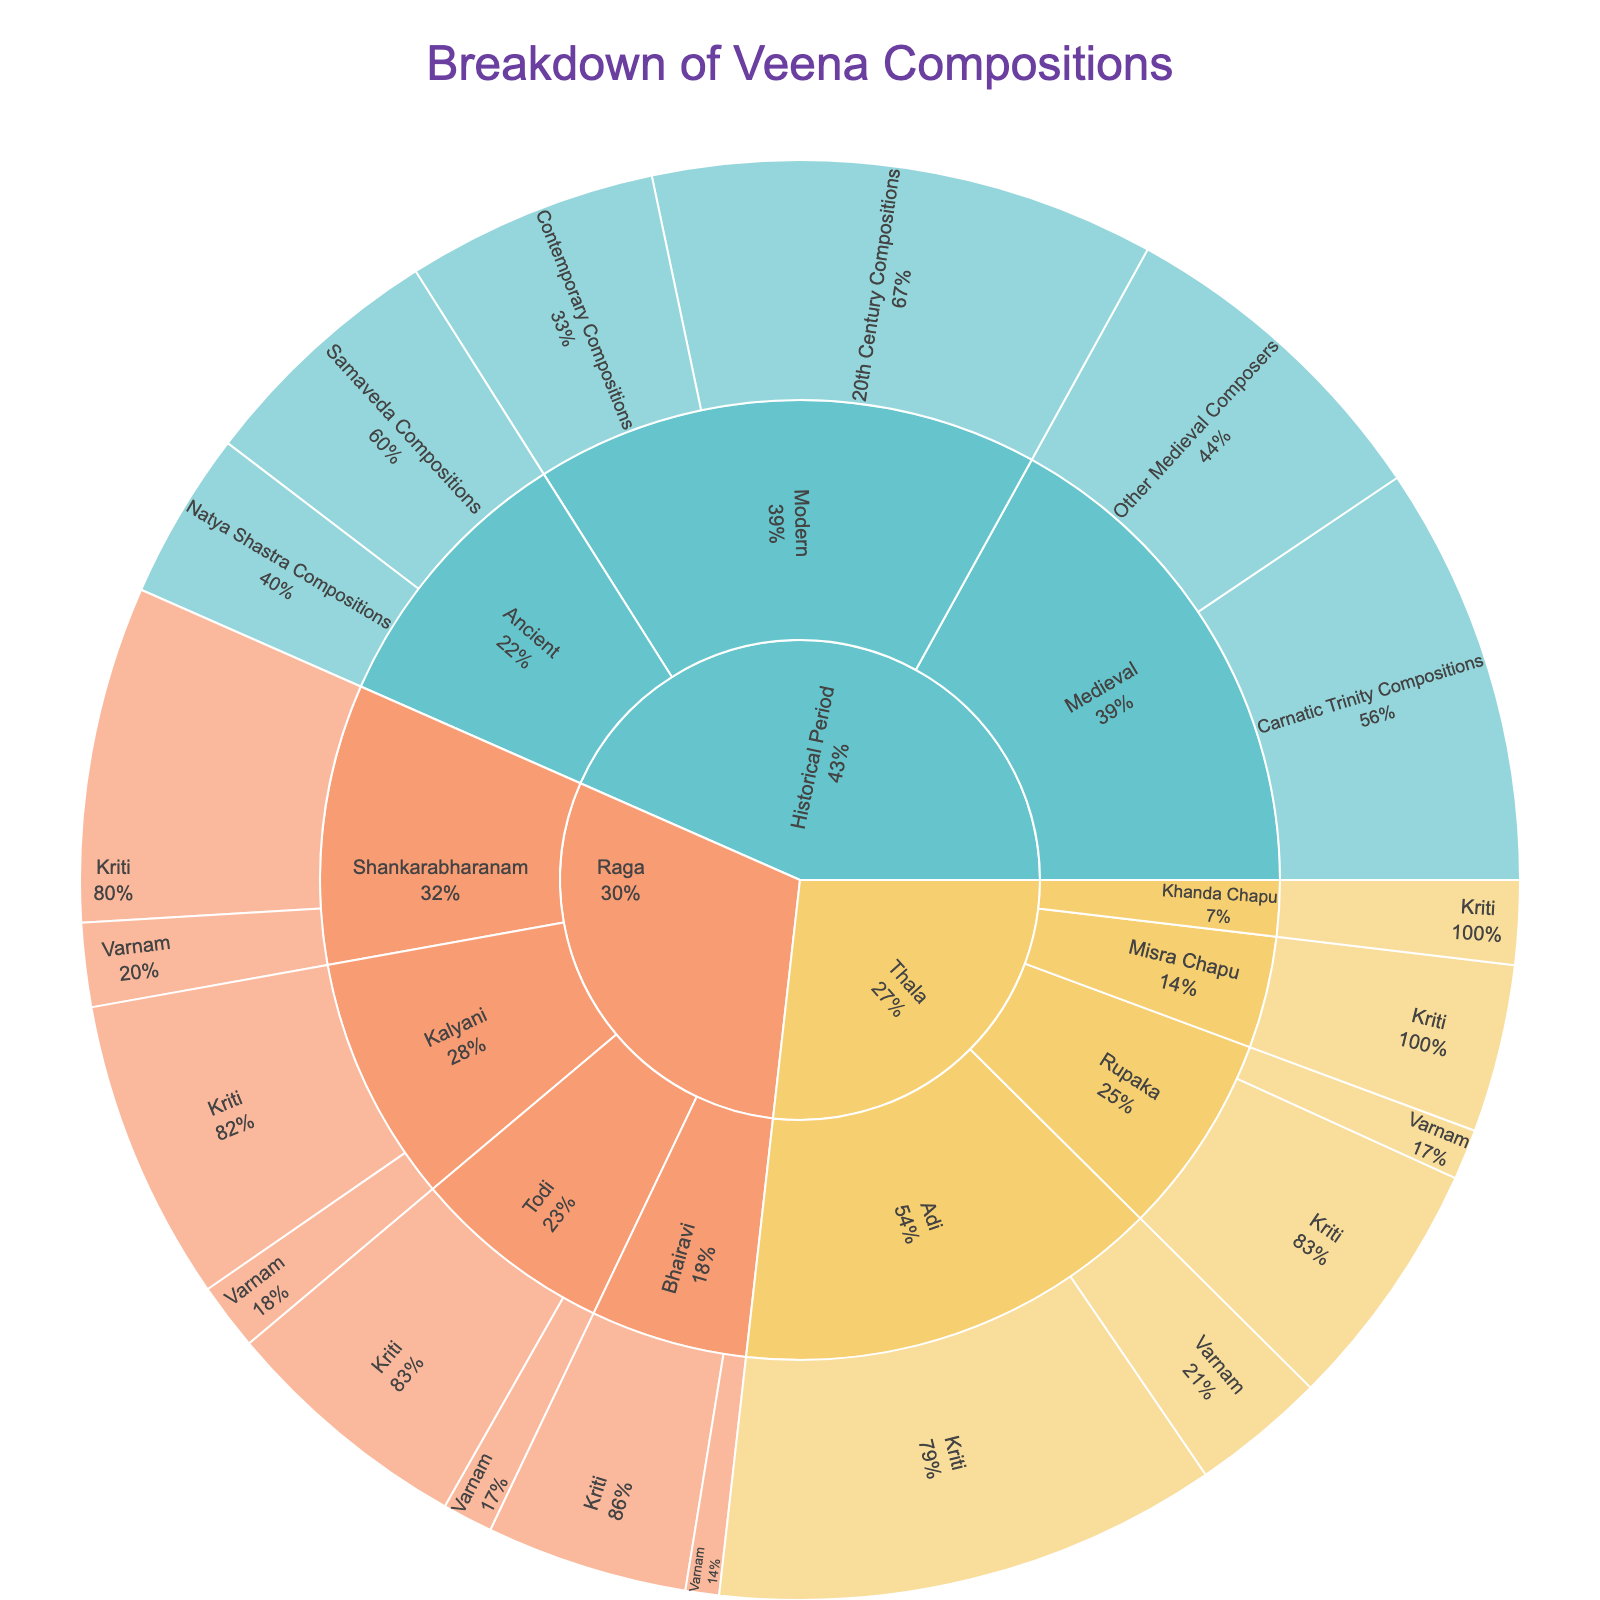What's the total number of compositions listed in the plot? Sum all individual values from each segment: 15 (Samaveda) + 10 (Natya Shastra) + 25 (Carnatic Trinity) + 20 (Other Medieval) + 30 (20th Century) + 15 (Contemporary) + 20 (Shankarabharanam Kriti) + 5 (Shankarabharanam Varnam) + 15 (Todi Kriti) + 3 (Todi Varnam) + 18 (Kalyani Kriti) + 4 (Kalyani Varnam) + 12 (Bhairavi Kriti) + 2 (Bhairavi Varnam) + 30 (Adi Kriti) + 8 (Adi Varnam) + 15 (Rupaka Kriti) + 3 (Rupaka Varnam) + 10 (Misra Chapu Kriti) + 5 (Khanda Chapu Kriti) = 285
Answer: 285 Which historical period has the highest number of compositions? Refer to the segments under 'Historical Period', compare their values: Ancient (15 + 10 = 25), Medieval (25 + 20 = 45), Modern (30 + 15 = 45). Both Medieval and Modern have the highest number of compositions (45 each).
Answer: Medieval and Modern What's the percentage of Adi thala compositions out of all Thala compositions? Calculate the total for Thala: 30 (Adi Kriti) + 8 (Adi Varnam) + 15 (Rupaka Kriti) + 3 (Rupaka Varnam) + 10 (Misra Chapu Kriti) + 5 (Khanda Chapu Kriti) = 71. Then calculate Adi Thala: 30 + 8 = 38. Percentage: (38/71) * 100 ≈ 53.5%
Answer: 53.5% How do the compositions in Shankarabharanam raga compare to those in Todi? Sum the values for each raga: Shankarabharanam (20 + 5 = 25), Todi (15 + 3 = 18). Thus, Shankarabharanam has more compositions than Todi.
Answer: Shankarabharanam has more compositions What fraction of the compositions from the Modern period comes from the 20th Century? Modern period total compositions: 30 (20th Century) + 15 (Contemporary) = 45. Fraction from 20th Century: 30/45 = 2/3.
Answer: 2/3 Which raga has the fewest Varnam compositions? Compare the Varnam compositions for each raga: Shankarabharanam (5), Todi (3), Kalyani (4), Bhairavi (2). Bhairavi has the fewest Varnam compositions.
Answer: Bhairavi How many more compositions are there in the Medieval period compared to the Ancient period? Medieval (45) vs. Ancient (25). Difference: 45 - 25 = 20.
Answer: 20 What proportion of all compositions are Contemporary Compositions? Total compositions: 285. Contemporary Compositions: 15. Proportion: 15/285 ≈ 0.0526 or 5.26%.
Answer: 5.26% How many compositions are in the Misra Chapu thala? Refer to the segment for Misra Chapu: 10 (Kriti).
Answer: 10 Which raga has the highest combined value of Kriti and Varnam compositions? Sum the values for each raga: Shankarabharanam (20 + 5 = 25), Todi (15 + 3 = 18), Kalyani (18 + 4 = 22), Bhairavi (12 + 2 = 14). Shankarabharanam has the highest combined value.
Answer: Shankarabharanam 